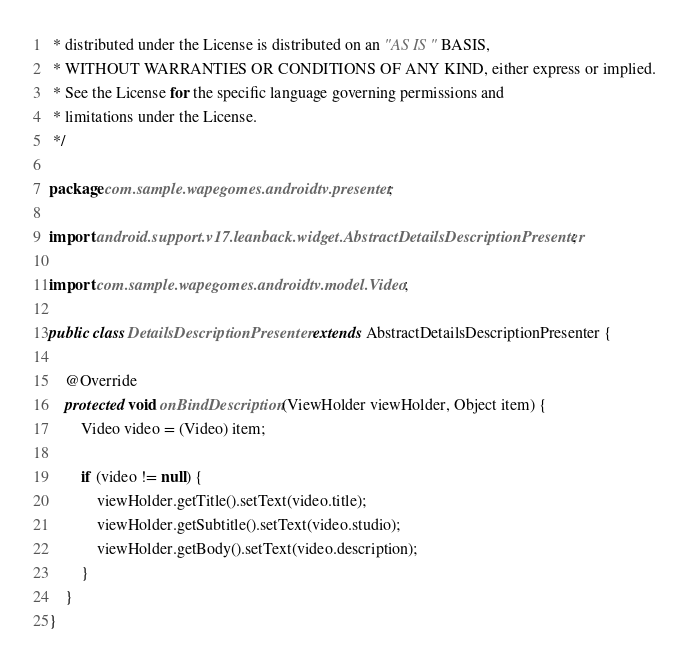<code> <loc_0><loc_0><loc_500><loc_500><_Java_> * distributed under the License is distributed on an "AS IS" BASIS,
 * WITHOUT WARRANTIES OR CONDITIONS OF ANY KIND, either express or implied.
 * See the License for the specific language governing permissions and
 * limitations under the License.
 */

package com.sample.wapegomes.androidtv.presenter;

import android.support.v17.leanback.widget.AbstractDetailsDescriptionPresenter;

import com.sample.wapegomes.androidtv.model.Video;

public class DetailsDescriptionPresenter extends AbstractDetailsDescriptionPresenter {

    @Override
    protected void onBindDescription(ViewHolder viewHolder, Object item) {
        Video video = (Video) item;

        if (video != null) {
            viewHolder.getTitle().setText(video.title);
            viewHolder.getSubtitle().setText(video.studio);
            viewHolder.getBody().setText(video.description);
        }
    }
}
</code> 